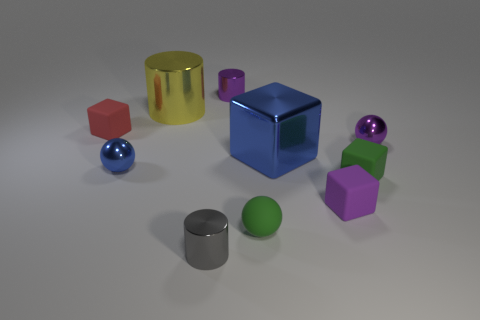What number of other objects are the same material as the big blue cube?
Ensure brevity in your answer.  5. There is a rubber thing that is left of the large blue block and in front of the red cube; what shape is it?
Keep it short and to the point. Sphere. There is a matte ball; is its color the same as the large metal object that is in front of the small purple shiny sphere?
Your answer should be very brief. No. There is a shiny ball that is to the left of the yellow object; is it the same size as the big metal block?
Keep it short and to the point. No. There is a tiny green object that is the same shape as the small blue metallic thing; what is its material?
Keep it short and to the point. Rubber. Is the large blue object the same shape as the red thing?
Make the answer very short. Yes. There is a tiny purple metal thing that is left of the tiny purple ball; how many rubber things are right of it?
Your answer should be compact. 3. There is a big blue thing that is made of the same material as the gray object; what is its shape?
Ensure brevity in your answer.  Cube. How many gray objects are tiny metal balls or rubber balls?
Your answer should be very brief. 0. There is a purple metallic object that is behind the tiny red object to the left of the green sphere; are there any blue metallic balls that are on the left side of it?
Make the answer very short. Yes. 